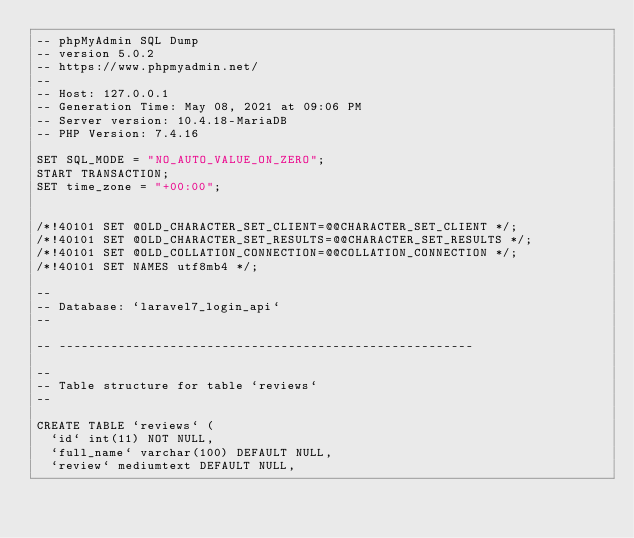<code> <loc_0><loc_0><loc_500><loc_500><_SQL_>-- phpMyAdmin SQL Dump
-- version 5.0.2
-- https://www.phpmyadmin.net/
--
-- Host: 127.0.0.1
-- Generation Time: May 08, 2021 at 09:06 PM
-- Server version: 10.4.18-MariaDB
-- PHP Version: 7.4.16

SET SQL_MODE = "NO_AUTO_VALUE_ON_ZERO";
START TRANSACTION;
SET time_zone = "+00:00";


/*!40101 SET @OLD_CHARACTER_SET_CLIENT=@@CHARACTER_SET_CLIENT */;
/*!40101 SET @OLD_CHARACTER_SET_RESULTS=@@CHARACTER_SET_RESULTS */;
/*!40101 SET @OLD_COLLATION_CONNECTION=@@COLLATION_CONNECTION */;
/*!40101 SET NAMES utf8mb4 */;

--
-- Database: `laravel7_login_api`
--

-- --------------------------------------------------------

--
-- Table structure for table `reviews`
--

CREATE TABLE `reviews` (
  `id` int(11) NOT NULL,
  `full_name` varchar(100) DEFAULT NULL,
  `review` mediumtext DEFAULT NULL,</code> 